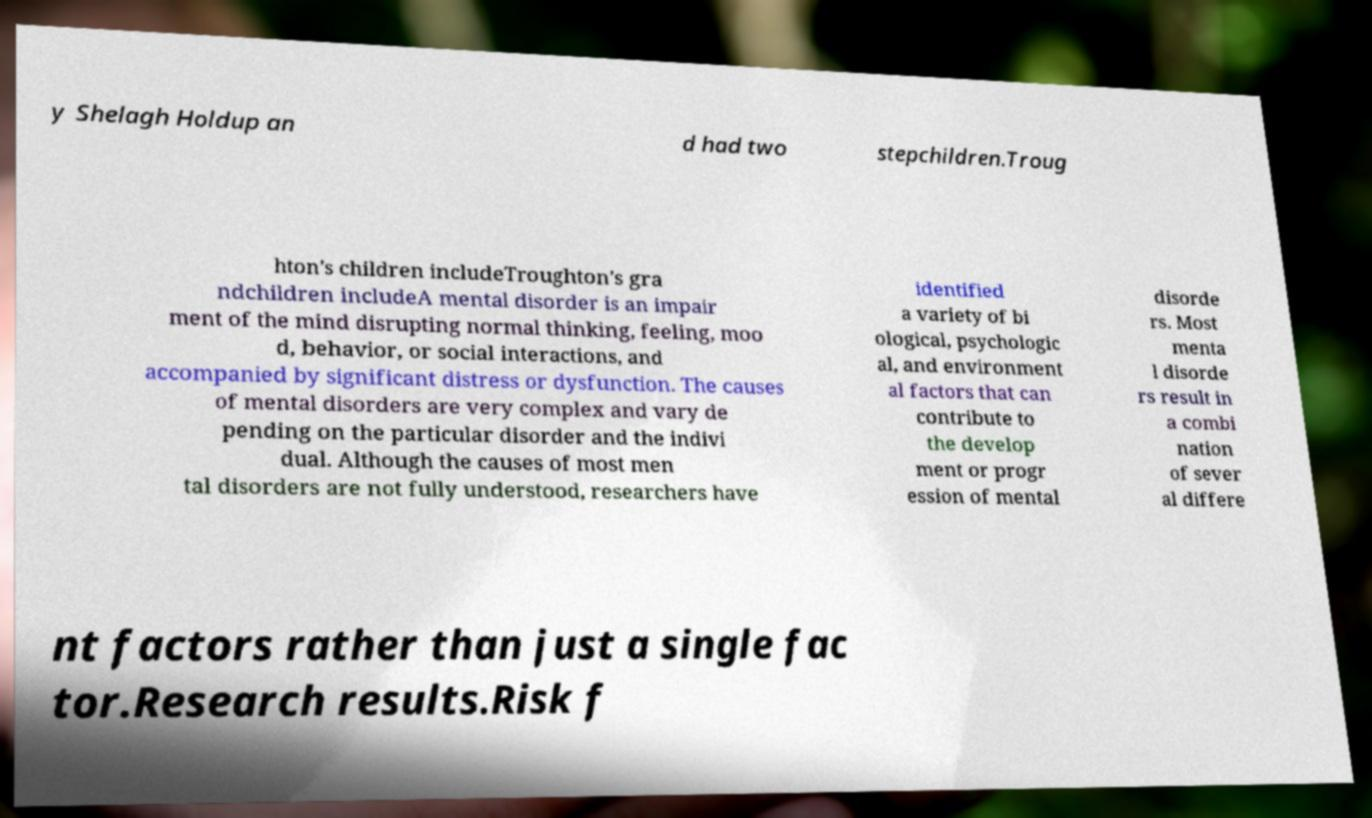What messages or text are displayed in this image? I need them in a readable, typed format. y Shelagh Holdup an d had two stepchildren.Troug hton's children includeTroughton's gra ndchildren includeA mental disorder is an impair ment of the mind disrupting normal thinking, feeling, moo d, behavior, or social interactions, and accompanied by significant distress or dysfunction. The causes of mental disorders are very complex and vary de pending on the particular disorder and the indivi dual. Although the causes of most men tal disorders are not fully understood, researchers have identified a variety of bi ological, psychologic al, and environment al factors that can contribute to the develop ment or progr ession of mental disorde rs. Most menta l disorde rs result in a combi nation of sever al differe nt factors rather than just a single fac tor.Research results.Risk f 